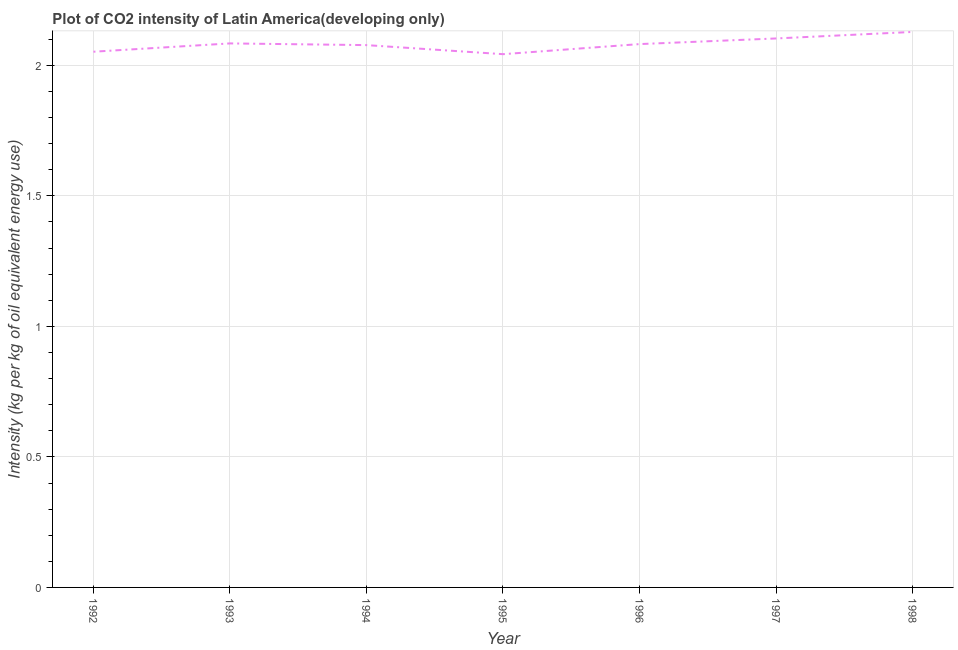What is the co2 intensity in 1993?
Ensure brevity in your answer.  2.08. Across all years, what is the maximum co2 intensity?
Provide a succinct answer. 2.13. Across all years, what is the minimum co2 intensity?
Give a very brief answer. 2.04. In which year was the co2 intensity maximum?
Give a very brief answer. 1998. What is the sum of the co2 intensity?
Give a very brief answer. 14.57. What is the difference between the co2 intensity in 1993 and 1998?
Your answer should be compact. -0.04. What is the average co2 intensity per year?
Provide a succinct answer. 2.08. What is the median co2 intensity?
Your answer should be very brief. 2.08. In how many years, is the co2 intensity greater than 1.2 kg?
Offer a very short reply. 7. What is the ratio of the co2 intensity in 1994 to that in 1998?
Ensure brevity in your answer.  0.98. Is the co2 intensity in 1994 less than that in 1998?
Make the answer very short. Yes. What is the difference between the highest and the second highest co2 intensity?
Offer a very short reply. 0.02. Is the sum of the co2 intensity in 1994 and 1998 greater than the maximum co2 intensity across all years?
Your answer should be compact. Yes. What is the difference between the highest and the lowest co2 intensity?
Your answer should be very brief. 0.09. How many years are there in the graph?
Provide a succinct answer. 7. What is the difference between two consecutive major ticks on the Y-axis?
Offer a terse response. 0.5. Are the values on the major ticks of Y-axis written in scientific E-notation?
Provide a short and direct response. No. Does the graph contain grids?
Offer a very short reply. Yes. What is the title of the graph?
Offer a terse response. Plot of CO2 intensity of Latin America(developing only). What is the label or title of the X-axis?
Offer a terse response. Year. What is the label or title of the Y-axis?
Provide a short and direct response. Intensity (kg per kg of oil equivalent energy use). What is the Intensity (kg per kg of oil equivalent energy use) of 1992?
Keep it short and to the point. 2.05. What is the Intensity (kg per kg of oil equivalent energy use) in 1993?
Make the answer very short. 2.08. What is the Intensity (kg per kg of oil equivalent energy use) of 1994?
Your response must be concise. 2.08. What is the Intensity (kg per kg of oil equivalent energy use) in 1995?
Provide a short and direct response. 2.04. What is the Intensity (kg per kg of oil equivalent energy use) of 1996?
Provide a succinct answer. 2.08. What is the Intensity (kg per kg of oil equivalent energy use) in 1997?
Make the answer very short. 2.1. What is the Intensity (kg per kg of oil equivalent energy use) in 1998?
Offer a very short reply. 2.13. What is the difference between the Intensity (kg per kg of oil equivalent energy use) in 1992 and 1993?
Your response must be concise. -0.03. What is the difference between the Intensity (kg per kg of oil equivalent energy use) in 1992 and 1994?
Give a very brief answer. -0.03. What is the difference between the Intensity (kg per kg of oil equivalent energy use) in 1992 and 1995?
Provide a short and direct response. 0.01. What is the difference between the Intensity (kg per kg of oil equivalent energy use) in 1992 and 1996?
Ensure brevity in your answer.  -0.03. What is the difference between the Intensity (kg per kg of oil equivalent energy use) in 1992 and 1997?
Offer a very short reply. -0.05. What is the difference between the Intensity (kg per kg of oil equivalent energy use) in 1992 and 1998?
Offer a terse response. -0.08. What is the difference between the Intensity (kg per kg of oil equivalent energy use) in 1993 and 1994?
Keep it short and to the point. 0.01. What is the difference between the Intensity (kg per kg of oil equivalent energy use) in 1993 and 1995?
Ensure brevity in your answer.  0.04. What is the difference between the Intensity (kg per kg of oil equivalent energy use) in 1993 and 1996?
Your response must be concise. 0. What is the difference between the Intensity (kg per kg of oil equivalent energy use) in 1993 and 1997?
Provide a short and direct response. -0.02. What is the difference between the Intensity (kg per kg of oil equivalent energy use) in 1993 and 1998?
Your response must be concise. -0.04. What is the difference between the Intensity (kg per kg of oil equivalent energy use) in 1994 and 1995?
Give a very brief answer. 0.03. What is the difference between the Intensity (kg per kg of oil equivalent energy use) in 1994 and 1996?
Provide a short and direct response. -0. What is the difference between the Intensity (kg per kg of oil equivalent energy use) in 1994 and 1997?
Provide a short and direct response. -0.03. What is the difference between the Intensity (kg per kg of oil equivalent energy use) in 1994 and 1998?
Make the answer very short. -0.05. What is the difference between the Intensity (kg per kg of oil equivalent energy use) in 1995 and 1996?
Offer a very short reply. -0.04. What is the difference between the Intensity (kg per kg of oil equivalent energy use) in 1995 and 1997?
Your answer should be compact. -0.06. What is the difference between the Intensity (kg per kg of oil equivalent energy use) in 1995 and 1998?
Your response must be concise. -0.09. What is the difference between the Intensity (kg per kg of oil equivalent energy use) in 1996 and 1997?
Ensure brevity in your answer.  -0.02. What is the difference between the Intensity (kg per kg of oil equivalent energy use) in 1996 and 1998?
Your response must be concise. -0.05. What is the difference between the Intensity (kg per kg of oil equivalent energy use) in 1997 and 1998?
Offer a very short reply. -0.02. What is the ratio of the Intensity (kg per kg of oil equivalent energy use) in 1992 to that in 1994?
Provide a short and direct response. 0.99. What is the ratio of the Intensity (kg per kg of oil equivalent energy use) in 1993 to that in 1994?
Offer a very short reply. 1. What is the ratio of the Intensity (kg per kg of oil equivalent energy use) in 1993 to that in 1996?
Give a very brief answer. 1. What is the ratio of the Intensity (kg per kg of oil equivalent energy use) in 1993 to that in 1997?
Your answer should be compact. 0.99. What is the ratio of the Intensity (kg per kg of oil equivalent energy use) in 1994 to that in 1995?
Give a very brief answer. 1.02. What is the ratio of the Intensity (kg per kg of oil equivalent energy use) in 1994 to that in 1997?
Make the answer very short. 0.99. What is the ratio of the Intensity (kg per kg of oil equivalent energy use) in 1994 to that in 1998?
Your answer should be compact. 0.98. What is the ratio of the Intensity (kg per kg of oil equivalent energy use) in 1996 to that in 1998?
Offer a very short reply. 0.98. 